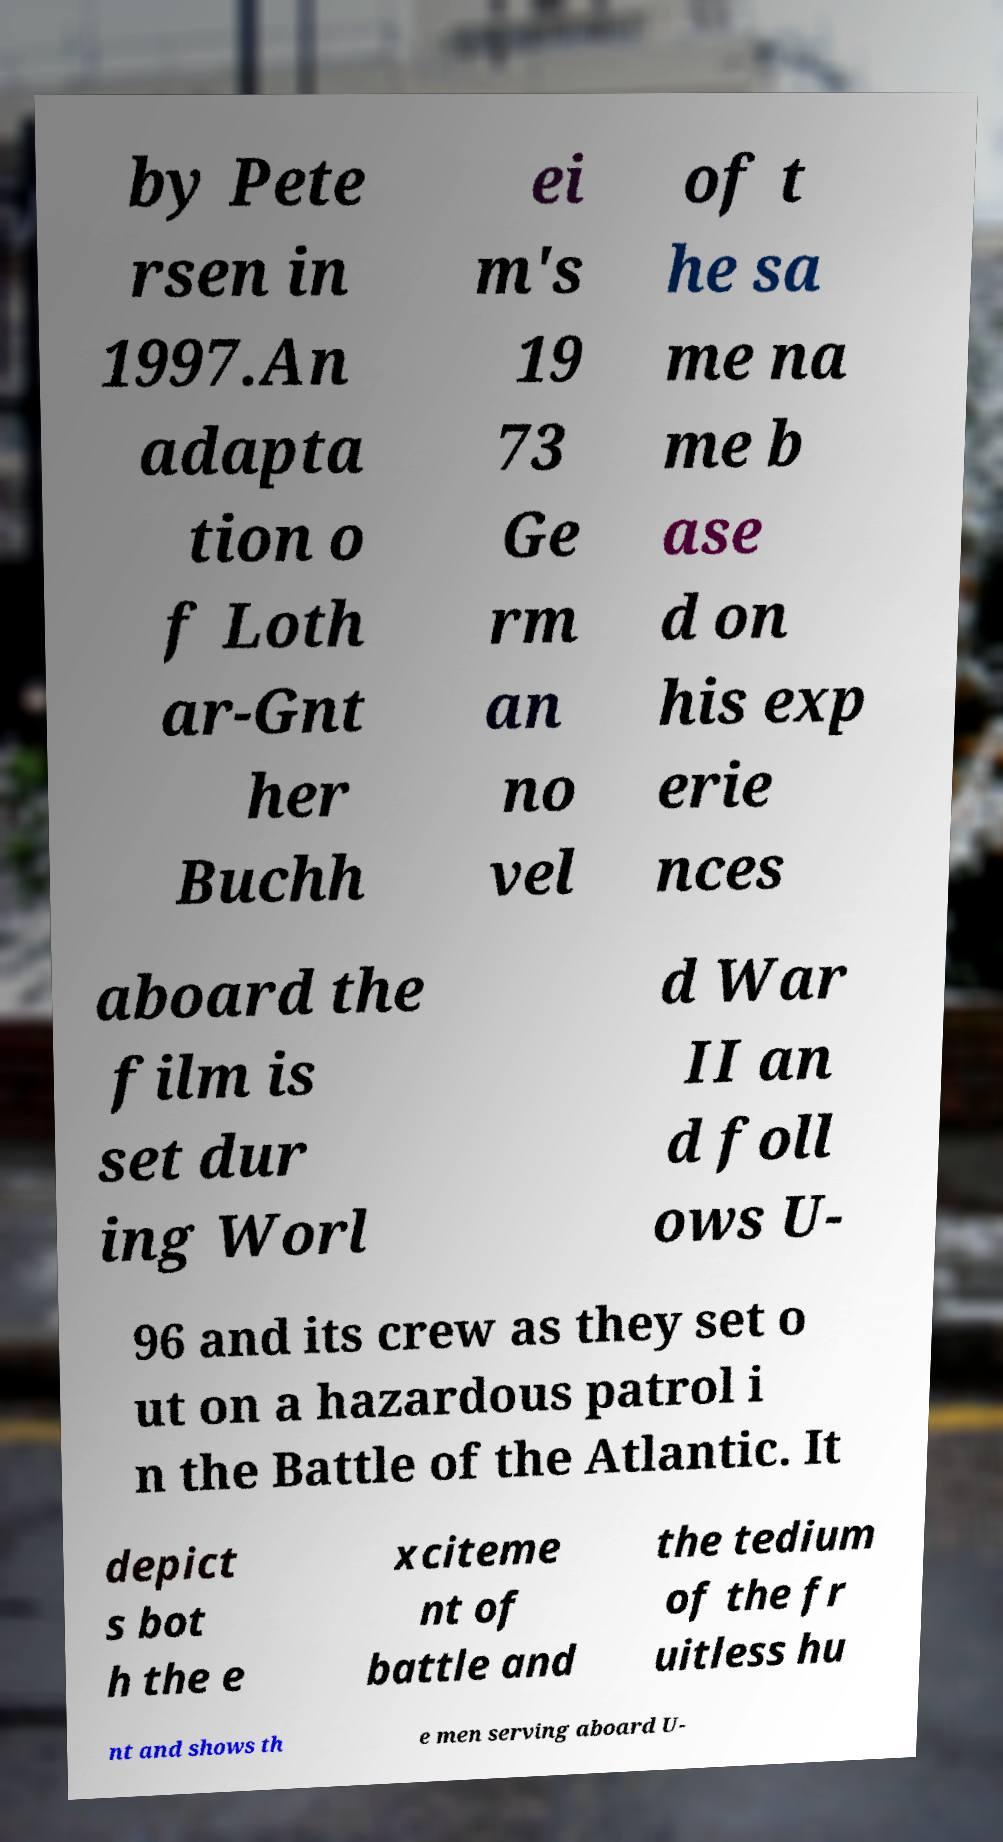Could you extract and type out the text from this image? by Pete rsen in 1997.An adapta tion o f Loth ar-Gnt her Buchh ei m's 19 73 Ge rm an no vel of t he sa me na me b ase d on his exp erie nces aboard the film is set dur ing Worl d War II an d foll ows U- 96 and its crew as they set o ut on a hazardous patrol i n the Battle of the Atlantic. It depict s bot h the e xciteme nt of battle and the tedium of the fr uitless hu nt and shows th e men serving aboard U- 